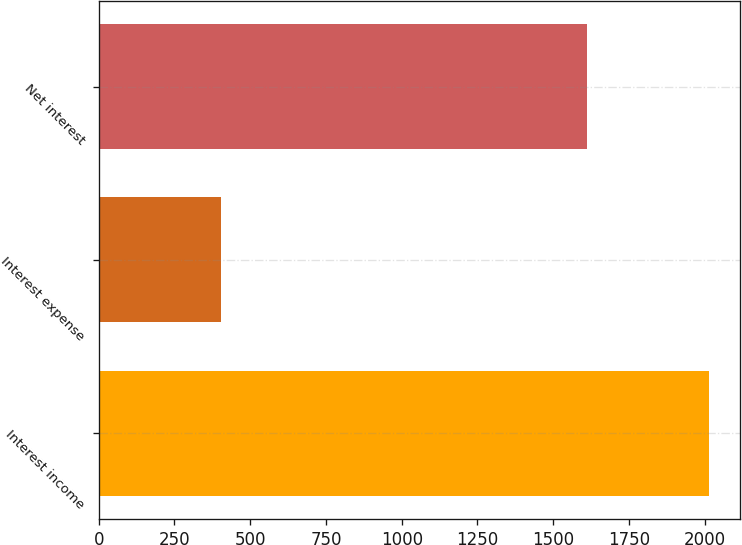<chart> <loc_0><loc_0><loc_500><loc_500><bar_chart><fcel>Interest income<fcel>Interest expense<fcel>Net interest<nl><fcel>2015<fcel>403<fcel>1612<nl></chart> 